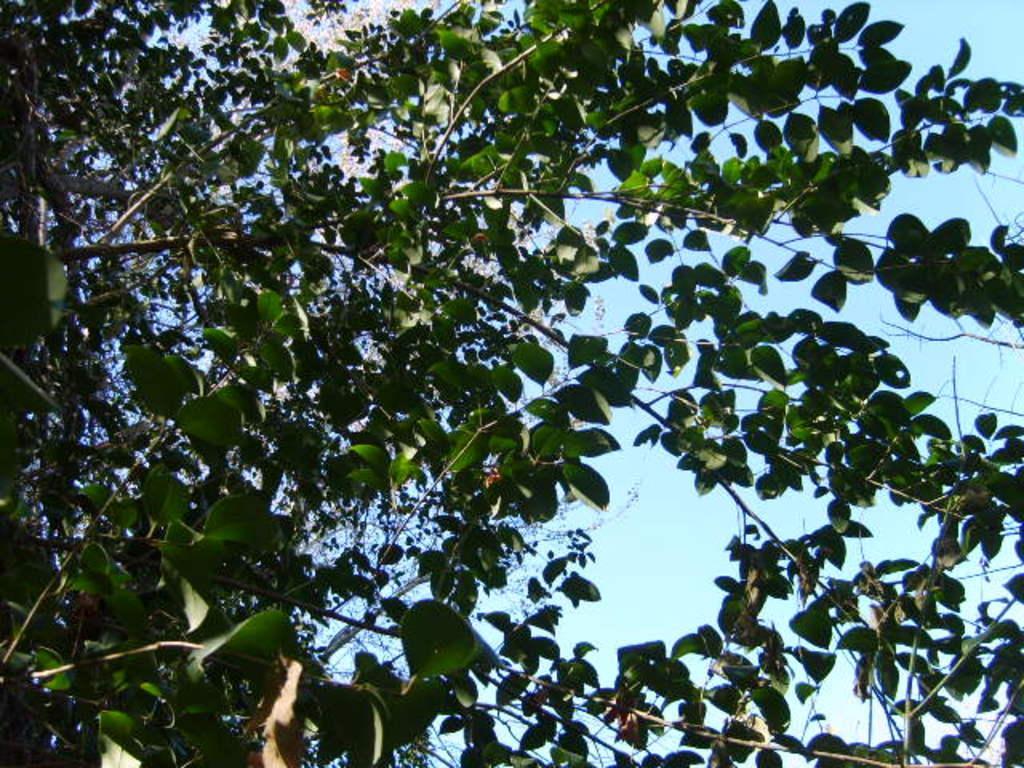Please provide a concise description of this image. In this image, we can see there are branches of the trees, which are having green color leaves. In the background, there are clouds in the blue sky. 